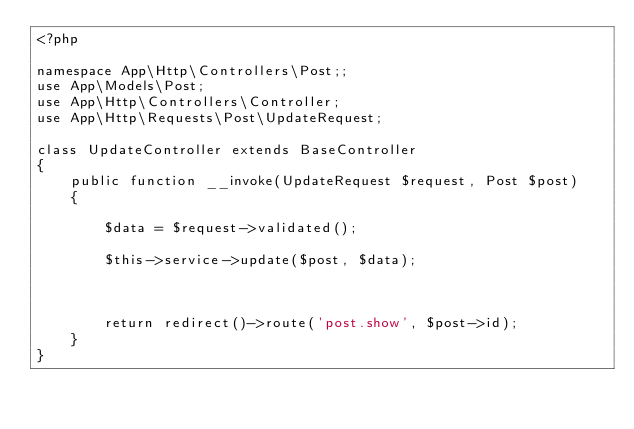Convert code to text. <code><loc_0><loc_0><loc_500><loc_500><_PHP_><?php

namespace App\Http\Controllers\Post;;
use App\Models\Post;
use App\Http\Controllers\Controller;
use App\Http\Requests\Post\UpdateRequest;

class UpdateController extends BaseController
{
    public function __invoke(UpdateRequest $request, Post $post)
    {
        
        $data = $request->validated();
        
        $this->service->update($post, $data);
        
        
        
        return redirect()->route('post.show', $post->id);
    }
}
</code> 